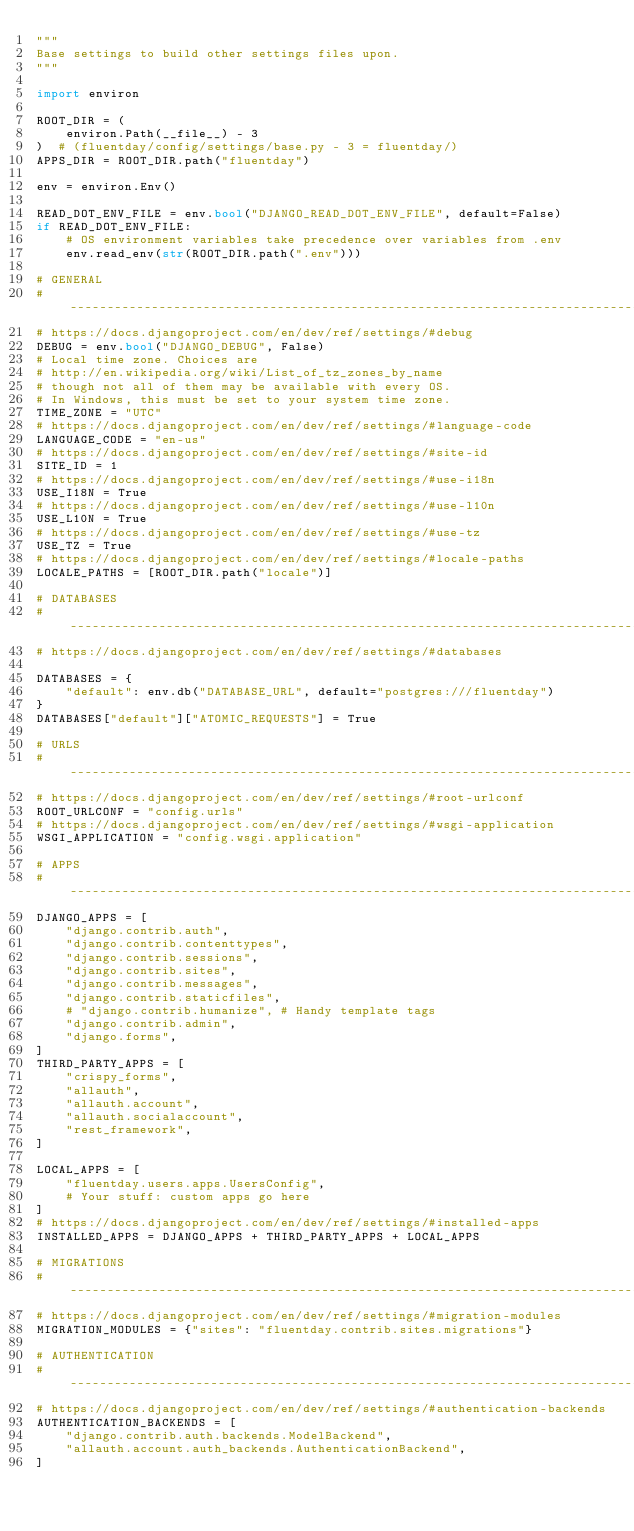<code> <loc_0><loc_0><loc_500><loc_500><_Python_>"""
Base settings to build other settings files upon.
"""

import environ

ROOT_DIR = (
    environ.Path(__file__) - 3
)  # (fluentday/config/settings/base.py - 3 = fluentday/)
APPS_DIR = ROOT_DIR.path("fluentday")

env = environ.Env()

READ_DOT_ENV_FILE = env.bool("DJANGO_READ_DOT_ENV_FILE", default=False)
if READ_DOT_ENV_FILE:
    # OS environment variables take precedence over variables from .env
    env.read_env(str(ROOT_DIR.path(".env")))

# GENERAL
# ------------------------------------------------------------------------------
# https://docs.djangoproject.com/en/dev/ref/settings/#debug
DEBUG = env.bool("DJANGO_DEBUG", False)
# Local time zone. Choices are
# http://en.wikipedia.org/wiki/List_of_tz_zones_by_name
# though not all of them may be available with every OS.
# In Windows, this must be set to your system time zone.
TIME_ZONE = "UTC"
# https://docs.djangoproject.com/en/dev/ref/settings/#language-code
LANGUAGE_CODE = "en-us"
# https://docs.djangoproject.com/en/dev/ref/settings/#site-id
SITE_ID = 1
# https://docs.djangoproject.com/en/dev/ref/settings/#use-i18n
USE_I18N = True
# https://docs.djangoproject.com/en/dev/ref/settings/#use-l10n
USE_L10N = True
# https://docs.djangoproject.com/en/dev/ref/settings/#use-tz
USE_TZ = True
# https://docs.djangoproject.com/en/dev/ref/settings/#locale-paths
LOCALE_PATHS = [ROOT_DIR.path("locale")]

# DATABASES
# ------------------------------------------------------------------------------
# https://docs.djangoproject.com/en/dev/ref/settings/#databases

DATABASES = {
    "default": env.db("DATABASE_URL", default="postgres:///fluentday")
}
DATABASES["default"]["ATOMIC_REQUESTS"] = True

# URLS
# ------------------------------------------------------------------------------
# https://docs.djangoproject.com/en/dev/ref/settings/#root-urlconf
ROOT_URLCONF = "config.urls"
# https://docs.djangoproject.com/en/dev/ref/settings/#wsgi-application
WSGI_APPLICATION = "config.wsgi.application"

# APPS
# ------------------------------------------------------------------------------
DJANGO_APPS = [
    "django.contrib.auth",
    "django.contrib.contenttypes",
    "django.contrib.sessions",
    "django.contrib.sites",
    "django.contrib.messages",
    "django.contrib.staticfiles",
    # "django.contrib.humanize", # Handy template tags
    "django.contrib.admin",
    "django.forms",
]
THIRD_PARTY_APPS = [
    "crispy_forms",
    "allauth",
    "allauth.account",
    "allauth.socialaccount",
    "rest_framework",
]

LOCAL_APPS = [
    "fluentday.users.apps.UsersConfig",
    # Your stuff: custom apps go here
]
# https://docs.djangoproject.com/en/dev/ref/settings/#installed-apps
INSTALLED_APPS = DJANGO_APPS + THIRD_PARTY_APPS + LOCAL_APPS

# MIGRATIONS
# ------------------------------------------------------------------------------
# https://docs.djangoproject.com/en/dev/ref/settings/#migration-modules
MIGRATION_MODULES = {"sites": "fluentday.contrib.sites.migrations"}

# AUTHENTICATION
# ------------------------------------------------------------------------------
# https://docs.djangoproject.com/en/dev/ref/settings/#authentication-backends
AUTHENTICATION_BACKENDS = [
    "django.contrib.auth.backends.ModelBackend",
    "allauth.account.auth_backends.AuthenticationBackend",
]</code> 